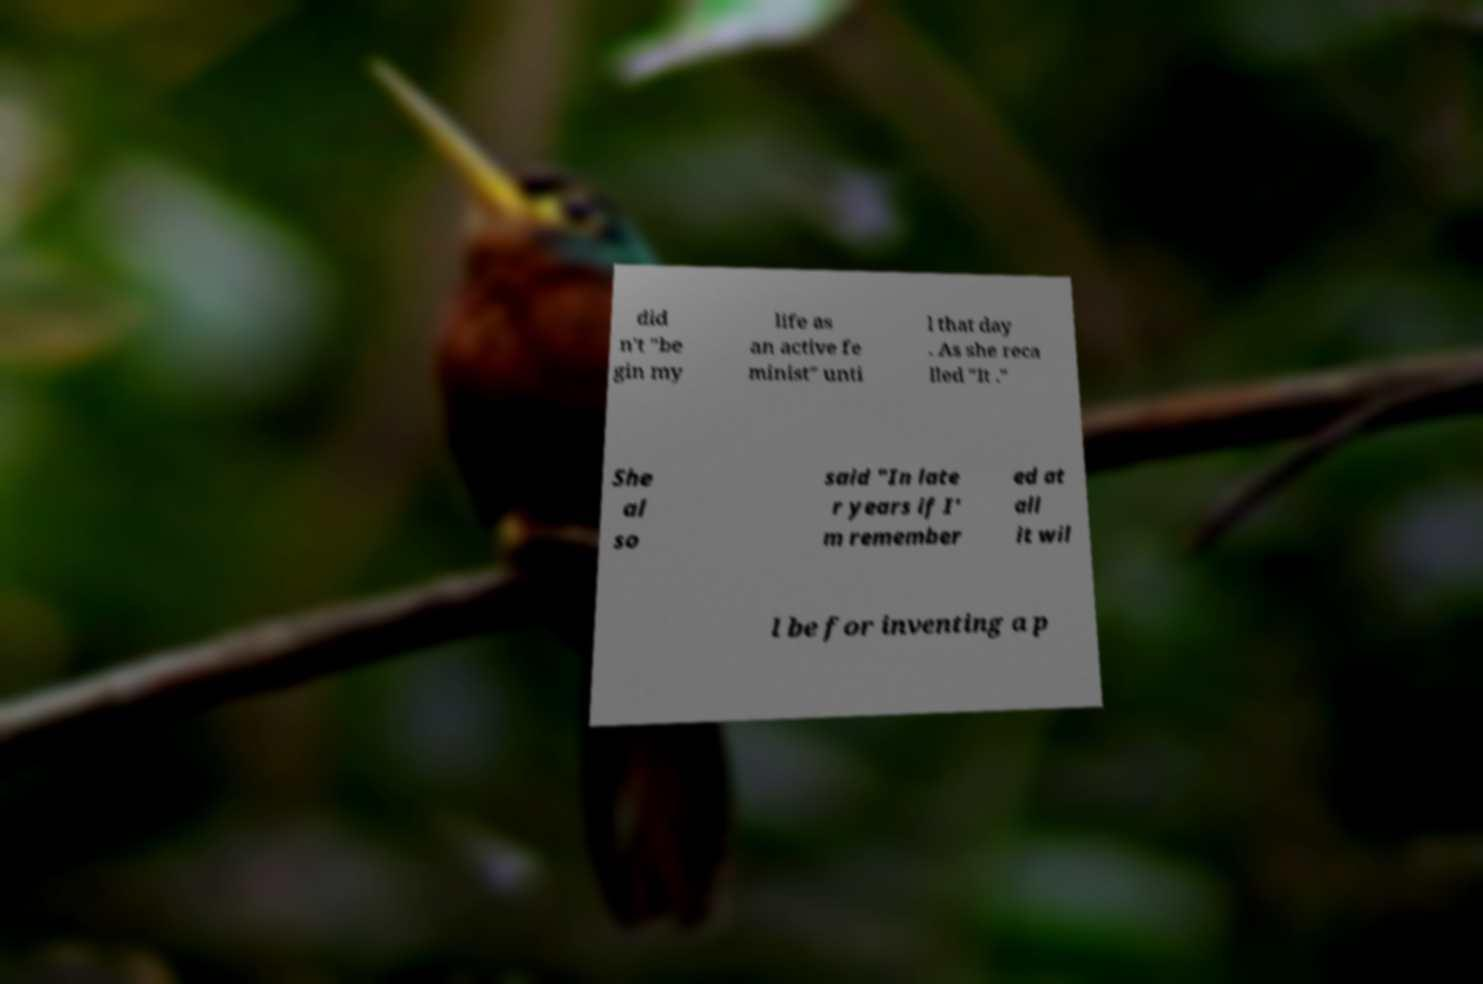Can you accurately transcribe the text from the provided image for me? did n't "be gin my life as an active fe minist" unti l that day . As she reca lled "It ." She al so said "In late r years if I' m remember ed at all it wil l be for inventing a p 